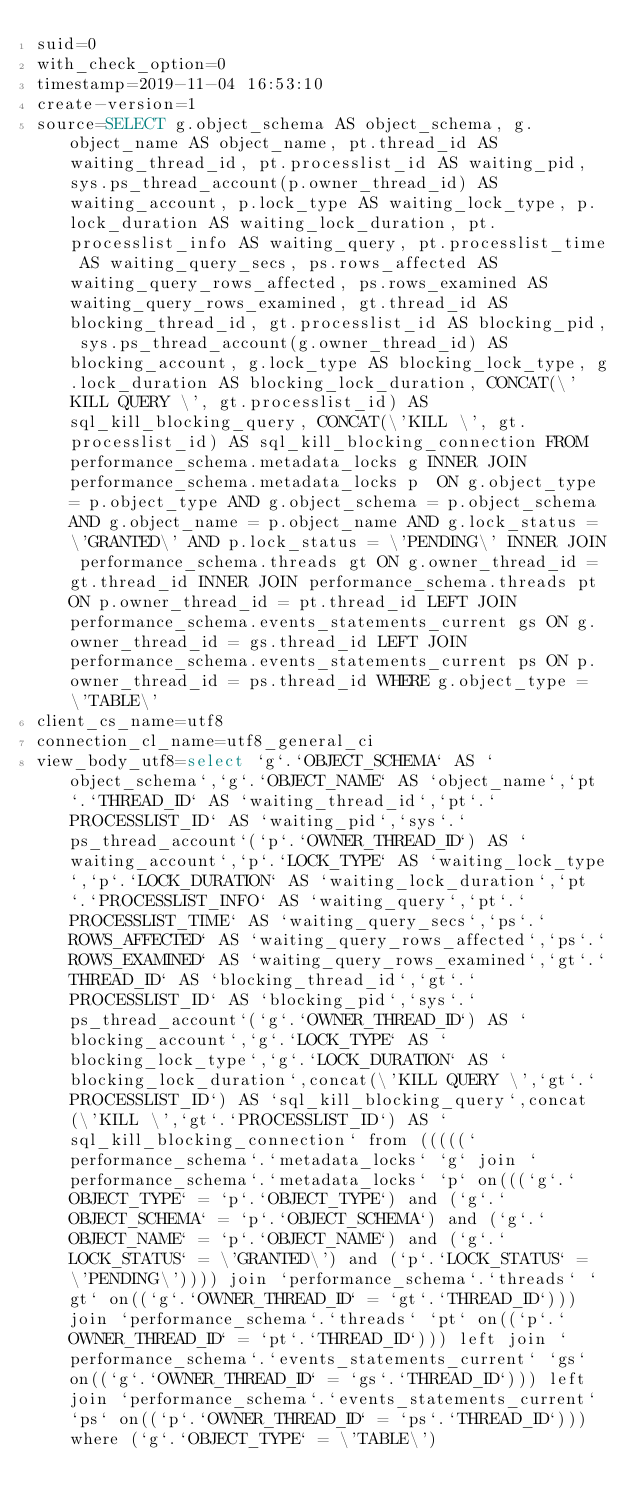Convert code to text. <code><loc_0><loc_0><loc_500><loc_500><_VisualBasic_>suid=0
with_check_option=0
timestamp=2019-11-04 16:53:10
create-version=1
source=SELECT g.object_schema AS object_schema, g.object_name AS object_name, pt.thread_id AS waiting_thread_id, pt.processlist_id AS waiting_pid, sys.ps_thread_account(p.owner_thread_id) AS waiting_account, p.lock_type AS waiting_lock_type, p.lock_duration AS waiting_lock_duration, pt.processlist_info AS waiting_query, pt.processlist_time AS waiting_query_secs, ps.rows_affected AS waiting_query_rows_affected, ps.rows_examined AS waiting_query_rows_examined, gt.thread_id AS blocking_thread_id, gt.processlist_id AS blocking_pid, sys.ps_thread_account(g.owner_thread_id) AS blocking_account, g.lock_type AS blocking_lock_type, g.lock_duration AS blocking_lock_duration, CONCAT(\'KILL QUERY \', gt.processlist_id) AS sql_kill_blocking_query, CONCAT(\'KILL \', gt.processlist_id) AS sql_kill_blocking_connection FROM performance_schema.metadata_locks g INNER JOIN performance_schema.metadata_locks p  ON g.object_type = p.object_type AND g.object_schema = p.object_schema AND g.object_name = p.object_name AND g.lock_status = \'GRANTED\' AND p.lock_status = \'PENDING\' INNER JOIN performance_schema.threads gt ON g.owner_thread_id = gt.thread_id INNER JOIN performance_schema.threads pt ON p.owner_thread_id = pt.thread_id LEFT JOIN performance_schema.events_statements_current gs ON g.owner_thread_id = gs.thread_id LEFT JOIN performance_schema.events_statements_current ps ON p.owner_thread_id = ps.thread_id WHERE g.object_type = \'TABLE\'
client_cs_name=utf8
connection_cl_name=utf8_general_ci
view_body_utf8=select `g`.`OBJECT_SCHEMA` AS `object_schema`,`g`.`OBJECT_NAME` AS `object_name`,`pt`.`THREAD_ID` AS `waiting_thread_id`,`pt`.`PROCESSLIST_ID` AS `waiting_pid`,`sys`.`ps_thread_account`(`p`.`OWNER_THREAD_ID`) AS `waiting_account`,`p`.`LOCK_TYPE` AS `waiting_lock_type`,`p`.`LOCK_DURATION` AS `waiting_lock_duration`,`pt`.`PROCESSLIST_INFO` AS `waiting_query`,`pt`.`PROCESSLIST_TIME` AS `waiting_query_secs`,`ps`.`ROWS_AFFECTED` AS `waiting_query_rows_affected`,`ps`.`ROWS_EXAMINED` AS `waiting_query_rows_examined`,`gt`.`THREAD_ID` AS `blocking_thread_id`,`gt`.`PROCESSLIST_ID` AS `blocking_pid`,`sys`.`ps_thread_account`(`g`.`OWNER_THREAD_ID`) AS `blocking_account`,`g`.`LOCK_TYPE` AS `blocking_lock_type`,`g`.`LOCK_DURATION` AS `blocking_lock_duration`,concat(\'KILL QUERY \',`gt`.`PROCESSLIST_ID`) AS `sql_kill_blocking_query`,concat(\'KILL \',`gt`.`PROCESSLIST_ID`) AS `sql_kill_blocking_connection` from (((((`performance_schema`.`metadata_locks` `g` join `performance_schema`.`metadata_locks` `p` on(((`g`.`OBJECT_TYPE` = `p`.`OBJECT_TYPE`) and (`g`.`OBJECT_SCHEMA` = `p`.`OBJECT_SCHEMA`) and (`g`.`OBJECT_NAME` = `p`.`OBJECT_NAME`) and (`g`.`LOCK_STATUS` = \'GRANTED\') and (`p`.`LOCK_STATUS` = \'PENDING\')))) join `performance_schema`.`threads` `gt` on((`g`.`OWNER_THREAD_ID` = `gt`.`THREAD_ID`))) join `performance_schema`.`threads` `pt` on((`p`.`OWNER_THREAD_ID` = `pt`.`THREAD_ID`))) left join `performance_schema`.`events_statements_current` `gs` on((`g`.`OWNER_THREAD_ID` = `gs`.`THREAD_ID`))) left join `performance_schema`.`events_statements_current` `ps` on((`p`.`OWNER_THREAD_ID` = `ps`.`THREAD_ID`))) where (`g`.`OBJECT_TYPE` = \'TABLE\')
</code> 